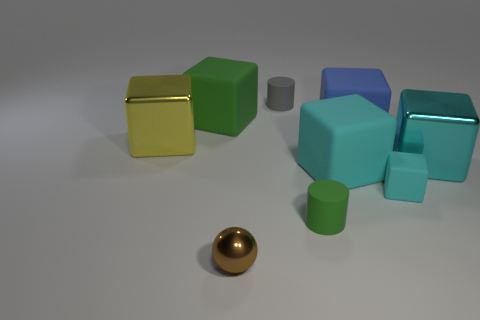Are there fewer brown shiny objects than small blue rubber cylinders?
Your answer should be compact. No. Do the small cylinder in front of the blue thing and the tiny metallic sphere have the same color?
Give a very brief answer. No. There is another large object that is the same material as the yellow object; what is its color?
Offer a terse response. Cyan. Is the brown metallic object the same size as the cyan metal thing?
Ensure brevity in your answer.  No. What is the material of the small block?
Provide a succinct answer. Rubber. There is a blue thing that is the same size as the yellow thing; what is it made of?
Provide a succinct answer. Rubber. Is there another gray thing that has the same size as the gray thing?
Make the answer very short. No. Are there an equal number of cylinders that are right of the green matte cylinder and small brown metal balls that are in front of the brown metal ball?
Make the answer very short. Yes. Is the number of yellow shiny things greater than the number of small cyan metallic objects?
Provide a short and direct response. Yes. What number of metal objects are small green objects or small cyan objects?
Ensure brevity in your answer.  0. 